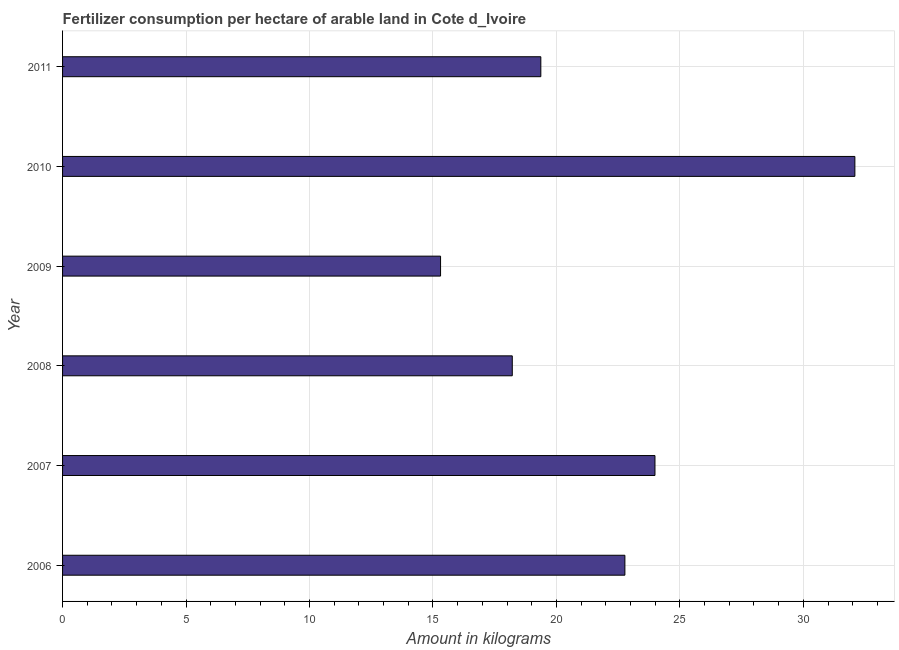Does the graph contain any zero values?
Your answer should be very brief. No. Does the graph contain grids?
Give a very brief answer. Yes. What is the title of the graph?
Offer a terse response. Fertilizer consumption per hectare of arable land in Cote d_Ivoire . What is the label or title of the X-axis?
Make the answer very short. Amount in kilograms. What is the amount of fertilizer consumption in 2010?
Offer a very short reply. 32.09. Across all years, what is the maximum amount of fertilizer consumption?
Keep it short and to the point. 32.09. Across all years, what is the minimum amount of fertilizer consumption?
Your answer should be very brief. 15.31. In which year was the amount of fertilizer consumption maximum?
Provide a succinct answer. 2010. What is the sum of the amount of fertilizer consumption?
Provide a short and direct response. 131.74. What is the difference between the amount of fertilizer consumption in 2007 and 2008?
Give a very brief answer. 5.78. What is the average amount of fertilizer consumption per year?
Keep it short and to the point. 21.96. What is the median amount of fertilizer consumption?
Your answer should be very brief. 21.07. In how many years, is the amount of fertilizer consumption greater than 13 kg?
Provide a short and direct response. 6. What is the ratio of the amount of fertilizer consumption in 2006 to that in 2010?
Give a very brief answer. 0.71. Is the amount of fertilizer consumption in 2009 less than that in 2010?
Your answer should be very brief. Yes. Is the difference between the amount of fertilizer consumption in 2007 and 2011 greater than the difference between any two years?
Offer a terse response. No. What is the difference between the highest and the second highest amount of fertilizer consumption?
Keep it short and to the point. 8.1. Is the sum of the amount of fertilizer consumption in 2008 and 2009 greater than the maximum amount of fertilizer consumption across all years?
Offer a very short reply. Yes. What is the difference between the highest and the lowest amount of fertilizer consumption?
Your answer should be very brief. 16.78. In how many years, is the amount of fertilizer consumption greater than the average amount of fertilizer consumption taken over all years?
Your response must be concise. 3. How many bars are there?
Your response must be concise. 6. Are all the bars in the graph horizontal?
Your answer should be very brief. Yes. Are the values on the major ticks of X-axis written in scientific E-notation?
Provide a short and direct response. No. What is the Amount in kilograms in 2006?
Give a very brief answer. 22.77. What is the Amount in kilograms in 2007?
Offer a terse response. 23.99. What is the Amount in kilograms in 2008?
Your answer should be very brief. 18.21. What is the Amount in kilograms in 2009?
Your answer should be compact. 15.31. What is the Amount in kilograms in 2010?
Offer a terse response. 32.09. What is the Amount in kilograms in 2011?
Give a very brief answer. 19.37. What is the difference between the Amount in kilograms in 2006 and 2007?
Your response must be concise. -1.22. What is the difference between the Amount in kilograms in 2006 and 2008?
Keep it short and to the point. 4.56. What is the difference between the Amount in kilograms in 2006 and 2009?
Make the answer very short. 7.46. What is the difference between the Amount in kilograms in 2006 and 2010?
Provide a succinct answer. -9.31. What is the difference between the Amount in kilograms in 2006 and 2011?
Your response must be concise. 3.4. What is the difference between the Amount in kilograms in 2007 and 2008?
Keep it short and to the point. 5.78. What is the difference between the Amount in kilograms in 2007 and 2009?
Your answer should be very brief. 8.68. What is the difference between the Amount in kilograms in 2007 and 2010?
Give a very brief answer. -8.1. What is the difference between the Amount in kilograms in 2007 and 2011?
Ensure brevity in your answer.  4.62. What is the difference between the Amount in kilograms in 2008 and 2009?
Offer a terse response. 2.9. What is the difference between the Amount in kilograms in 2008 and 2010?
Keep it short and to the point. -13.87. What is the difference between the Amount in kilograms in 2008 and 2011?
Provide a short and direct response. -1.16. What is the difference between the Amount in kilograms in 2009 and 2010?
Your answer should be compact. -16.78. What is the difference between the Amount in kilograms in 2009 and 2011?
Make the answer very short. -4.06. What is the difference between the Amount in kilograms in 2010 and 2011?
Keep it short and to the point. 12.72. What is the ratio of the Amount in kilograms in 2006 to that in 2007?
Your answer should be compact. 0.95. What is the ratio of the Amount in kilograms in 2006 to that in 2008?
Offer a very short reply. 1.25. What is the ratio of the Amount in kilograms in 2006 to that in 2009?
Make the answer very short. 1.49. What is the ratio of the Amount in kilograms in 2006 to that in 2010?
Provide a short and direct response. 0.71. What is the ratio of the Amount in kilograms in 2006 to that in 2011?
Provide a succinct answer. 1.18. What is the ratio of the Amount in kilograms in 2007 to that in 2008?
Offer a terse response. 1.32. What is the ratio of the Amount in kilograms in 2007 to that in 2009?
Your answer should be very brief. 1.57. What is the ratio of the Amount in kilograms in 2007 to that in 2010?
Your response must be concise. 0.75. What is the ratio of the Amount in kilograms in 2007 to that in 2011?
Give a very brief answer. 1.24. What is the ratio of the Amount in kilograms in 2008 to that in 2009?
Your answer should be compact. 1.19. What is the ratio of the Amount in kilograms in 2008 to that in 2010?
Provide a succinct answer. 0.57. What is the ratio of the Amount in kilograms in 2009 to that in 2010?
Ensure brevity in your answer.  0.48. What is the ratio of the Amount in kilograms in 2009 to that in 2011?
Your answer should be compact. 0.79. What is the ratio of the Amount in kilograms in 2010 to that in 2011?
Provide a succinct answer. 1.66. 